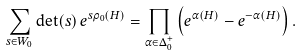<formula> <loc_0><loc_0><loc_500><loc_500>\sum _ { s \in W _ { 0 } } \det ( s ) \, e ^ { s \rho _ { 0 } ( H ) } = \prod _ { \alpha \in \Delta _ { 0 } ^ { + } } \left ( e ^ { \alpha ( H ) } - e ^ { - \alpha ( H ) } \right ) .</formula> 